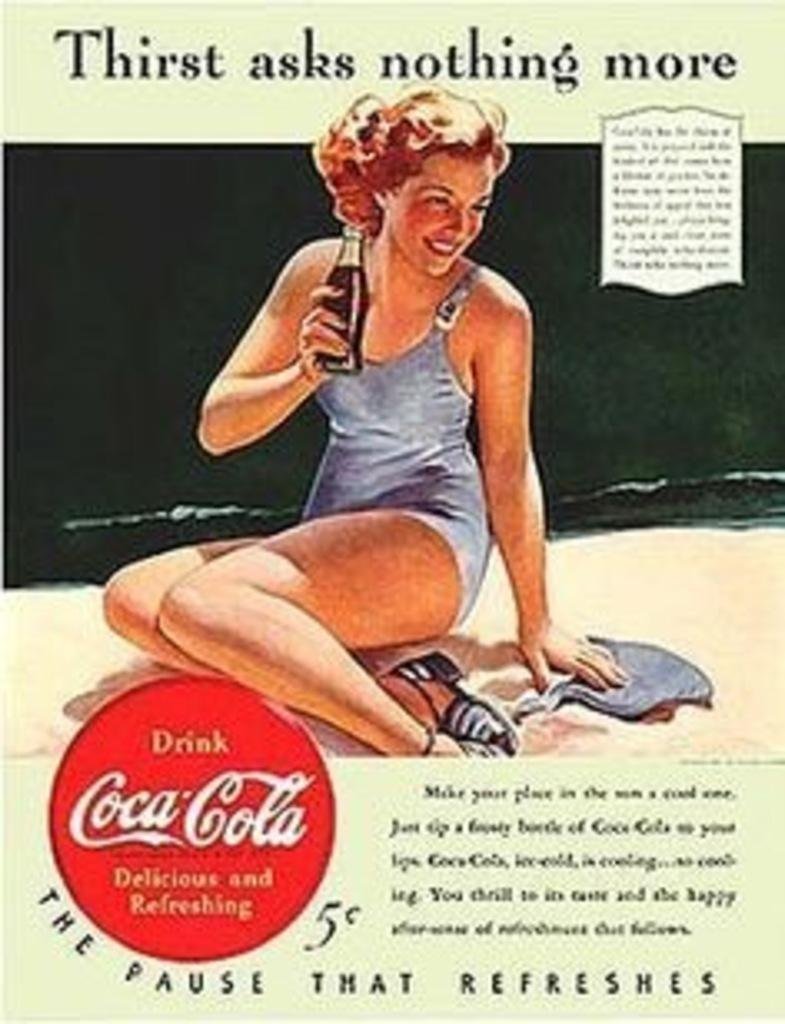What is present on the poster in the image? There is a poster in the image, and it features a woman. Is there any text on the poster? Yes, there is text written on the poster. How many worms can be seen crawling on the poster in the image? There are no worms present on the poster in the image. What type of spiders are depicted on the poster in the image? There are no spiders depicted on the poster in the image. 